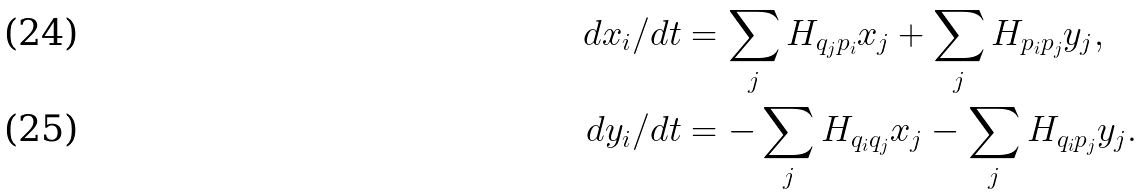Convert formula to latex. <formula><loc_0><loc_0><loc_500><loc_500>{ } d x _ { i } / d t & = \sum _ { j } H _ { q _ { j } p _ { i } } x _ { j } + \sum _ { j } H _ { p _ { i } p _ { j } } y _ { j } , \\ d y _ { i } / d t & = - \sum _ { j } H _ { q _ { i } q _ { j } } x _ { j } - \sum _ { j } H _ { q _ { i } p _ { j } } y _ { j } .</formula> 